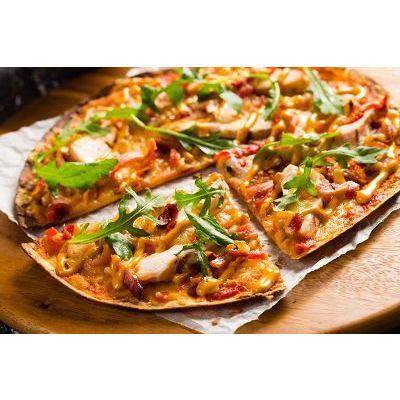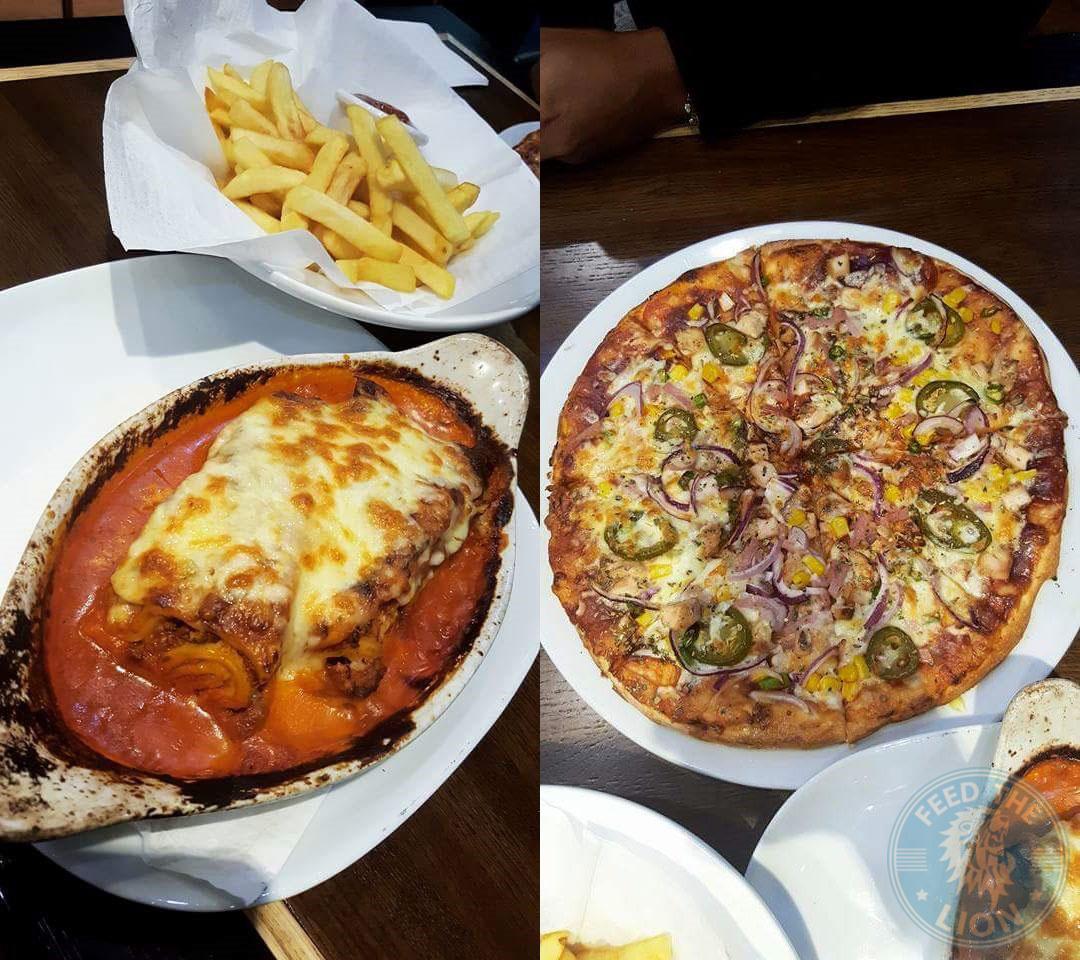The first image is the image on the left, the second image is the image on the right. Examine the images to the left and right. Is the description "The left image shows one round sliced pizza with a single slice out of place, and the right image contains more than one plate of food, including a pizza with green slices on top." accurate? Answer yes or no. Yes. 